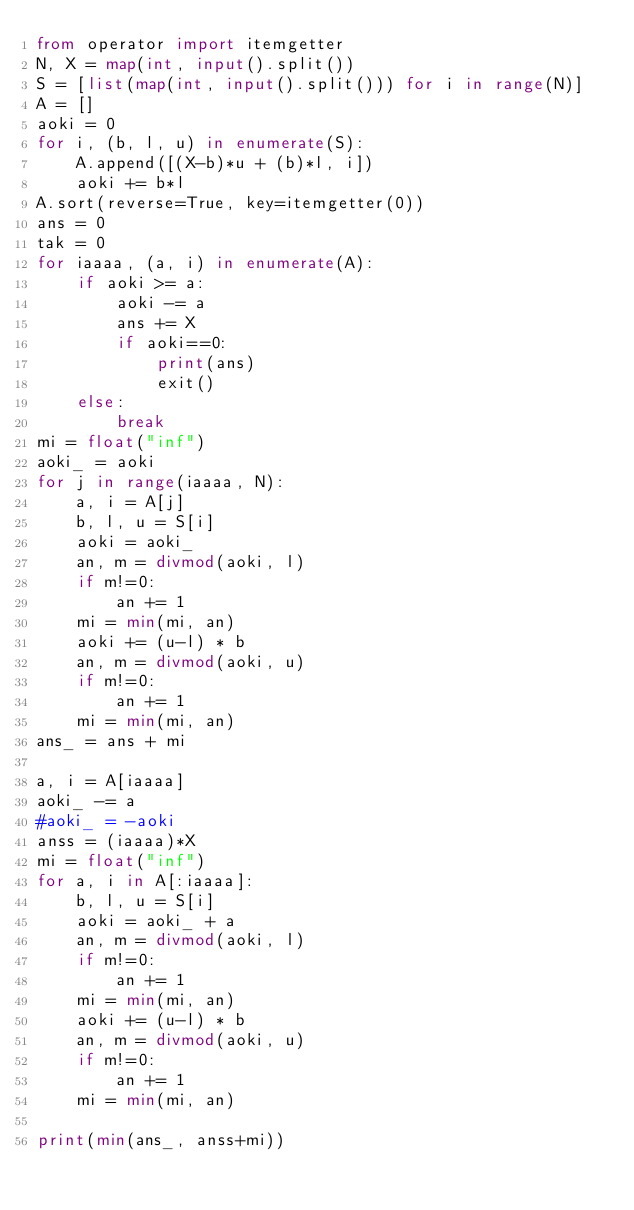Convert code to text. <code><loc_0><loc_0><loc_500><loc_500><_Python_>from operator import itemgetter
N, X = map(int, input().split())
S = [list(map(int, input().split())) for i in range(N)]
A = []
aoki = 0
for i, (b, l, u) in enumerate(S):
    A.append([(X-b)*u + (b)*l, i])
    aoki += b*l
A.sort(reverse=True, key=itemgetter(0))
ans = 0
tak = 0
for iaaaa, (a, i) in enumerate(A):
    if aoki >= a:
        aoki -= a
        ans += X
        if aoki==0:
            print(ans)
            exit()
    else:
        break
mi = float("inf")
aoki_ = aoki
for j in range(iaaaa, N):
    a, i = A[j]
    b, l, u = S[i]
    aoki = aoki_
    an, m = divmod(aoki, l)
    if m!=0:
        an += 1
    mi = min(mi, an)
    aoki += (u-l) * b
    an, m = divmod(aoki, u)
    if m!=0:
        an += 1
    mi = min(mi, an)
ans_ = ans + mi

a, i = A[iaaaa]
aoki_ -= a
#aoki_ = -aoki
anss = (iaaaa)*X
mi = float("inf")
for a, i in A[:iaaaa]:
    b, l, u = S[i]
    aoki = aoki_ + a
    an, m = divmod(aoki, l)
    if m!=0:
        an += 1
    mi = min(mi, an)
    aoki += (u-l) * b
    an, m = divmod(aoki, u)
    if m!=0:
        an += 1
    mi = min(mi, an)

print(min(ans_, anss+mi))
</code> 